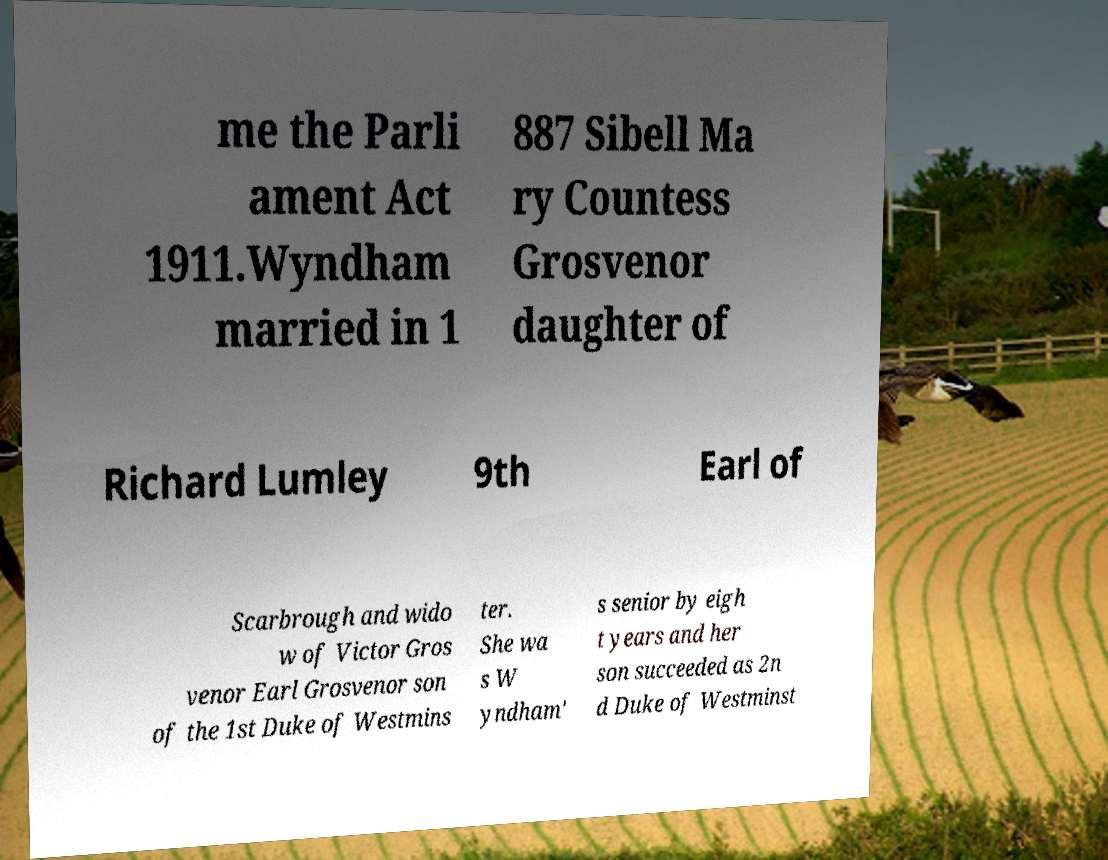Could you assist in decoding the text presented in this image and type it out clearly? me the Parli ament Act 1911.Wyndham married in 1 887 Sibell Ma ry Countess Grosvenor daughter of Richard Lumley 9th Earl of Scarbrough and wido w of Victor Gros venor Earl Grosvenor son of the 1st Duke of Westmins ter. She wa s W yndham' s senior by eigh t years and her son succeeded as 2n d Duke of Westminst 